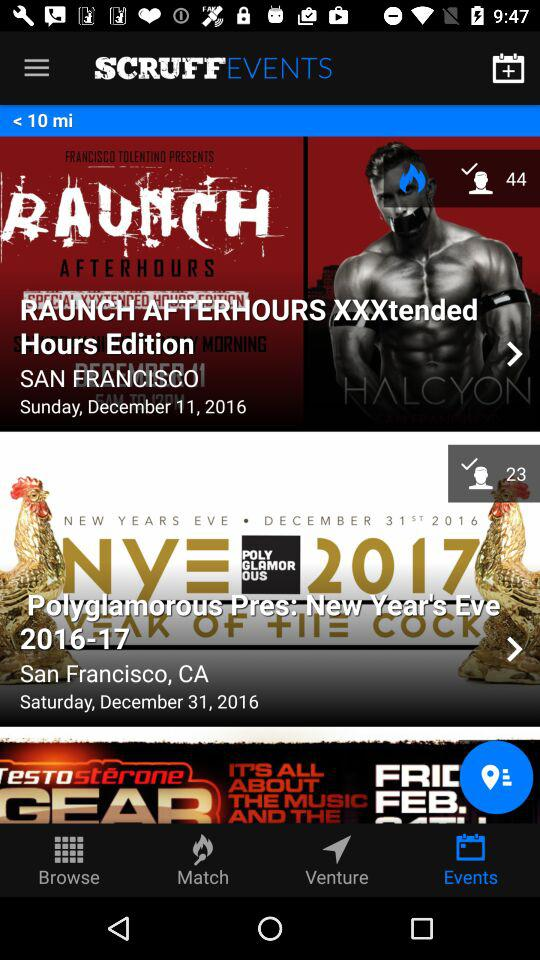What is the location of "Polyglamorous Pres: New Year's Eve 2016-17"? The location is San Francisco, CA. 